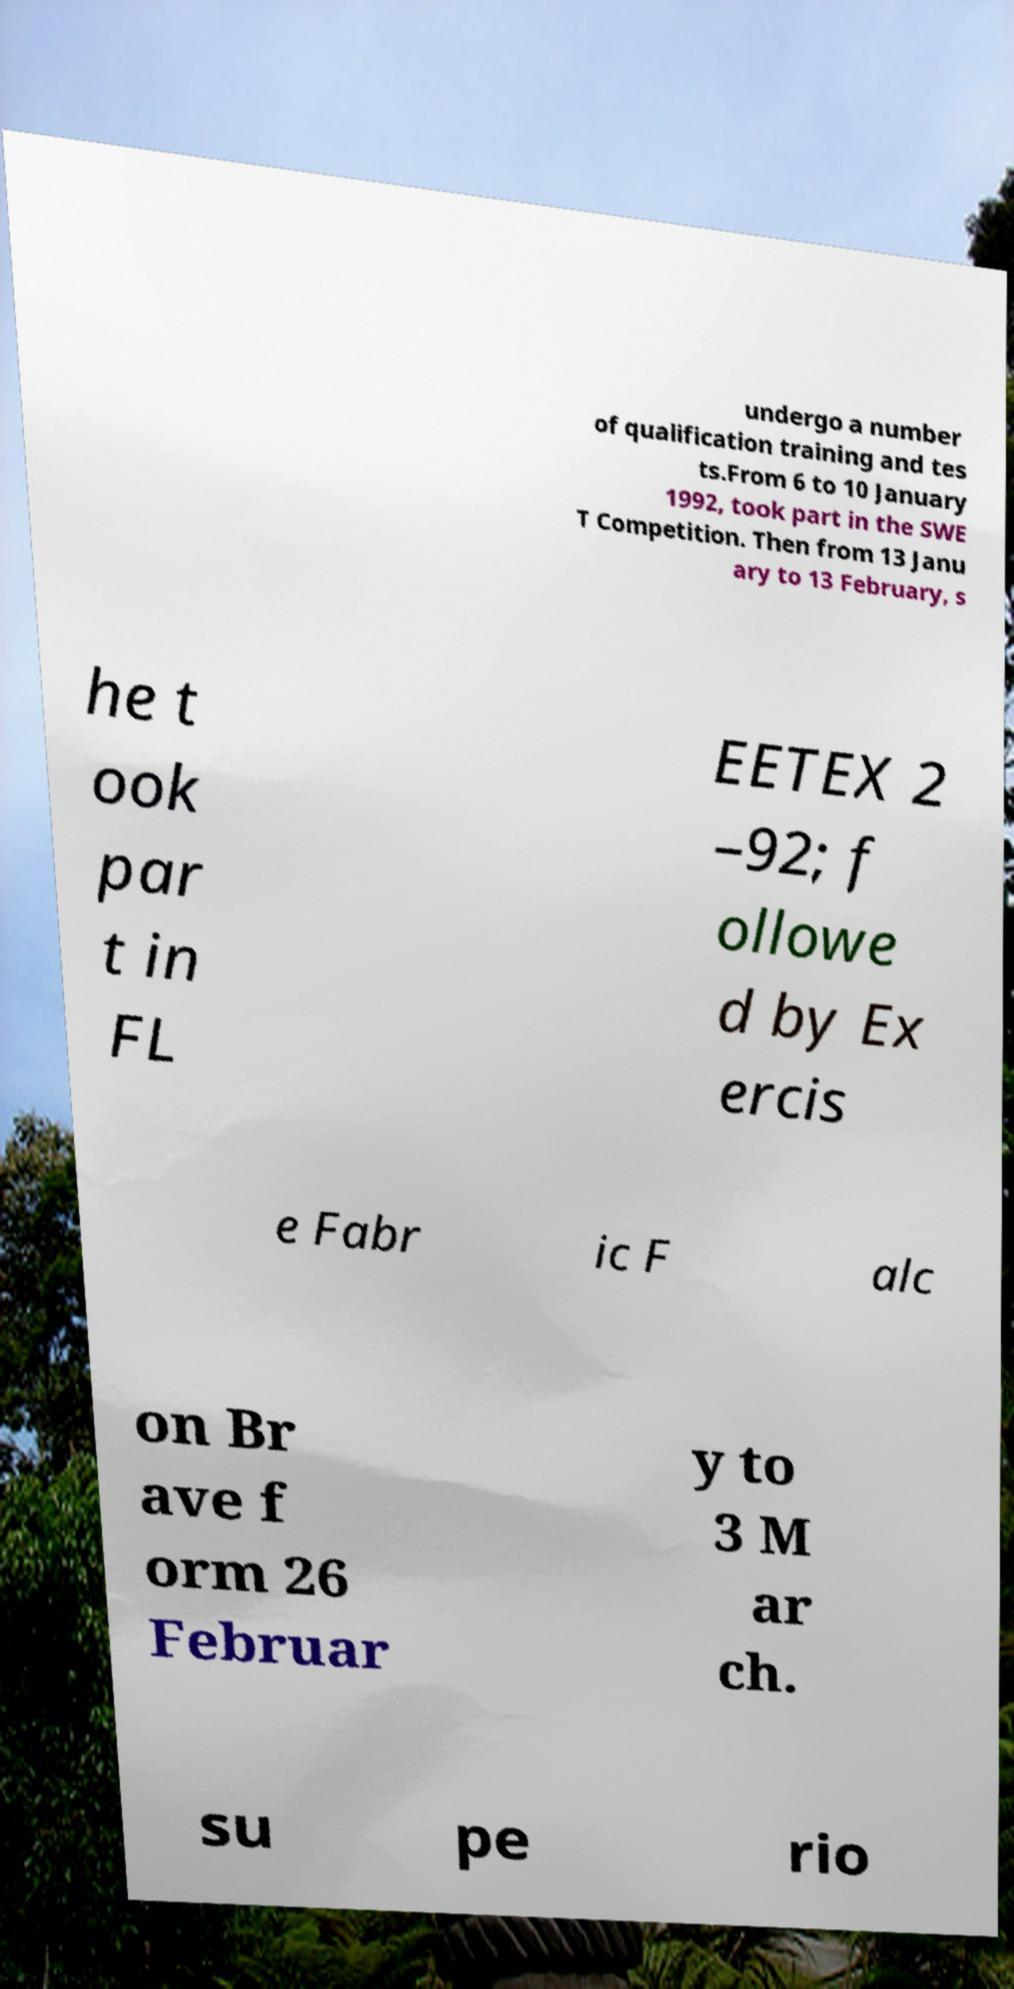Could you assist in decoding the text presented in this image and type it out clearly? undergo a number of qualification training and tes ts.From 6 to 10 January 1992, took part in the SWE T Competition. Then from 13 Janu ary to 13 February, s he t ook par t in FL EETEX 2 –92; f ollowe d by Ex ercis e Fabr ic F alc on Br ave f orm 26 Februar y to 3 M ar ch. su pe rio 